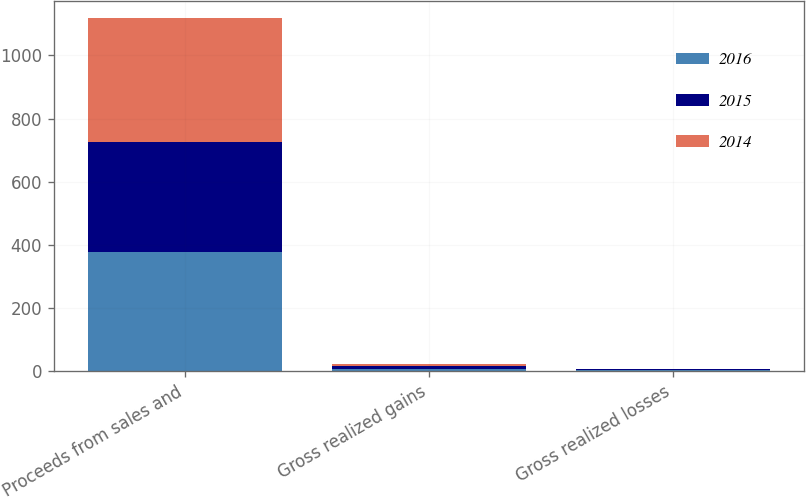Convert chart. <chart><loc_0><loc_0><loc_500><loc_500><stacked_bar_chart><ecel><fcel>Proceeds from sales and<fcel>Gross realized gains<fcel>Gross realized losses<nl><fcel>2016<fcel>377<fcel>7<fcel>4<nl><fcel>2015<fcel>349<fcel>8<fcel>2<nl><fcel>2014<fcel>391<fcel>7<fcel>2<nl></chart> 